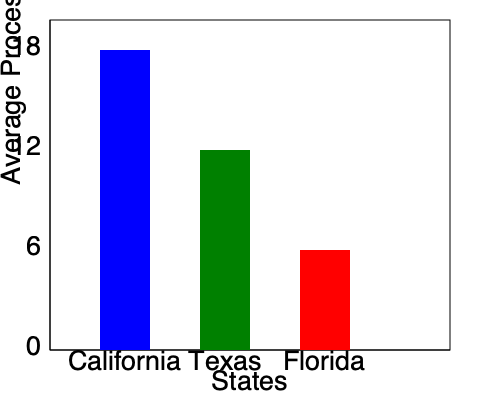Based on the bar graph showing average probate processing times for three states, which state has the shortest average processing time, and how much shorter is it compared to the state with the longest average processing time? To answer this question, we need to follow these steps:

1. Identify the average processing time for each state:
   - California (blue bar): 18 months
   - Texas (green bar): 12 months
   - Florida (red bar): 6 months

2. Determine the state with the shortest average processing time:
   Florida has the shortest bar, corresponding to 6 months.

3. Identify the state with the longest average processing time:
   California has the tallest bar, corresponding to 18 months.

4. Calculate the difference between the longest and shortest processing times:
   $18 \text{ months} - 6 \text{ months} = 12 \text{ months}$

Therefore, Florida has the shortest average processing time, and it is 12 months shorter than California, which has the longest average processing time.
Answer: Florida; 12 months shorter 